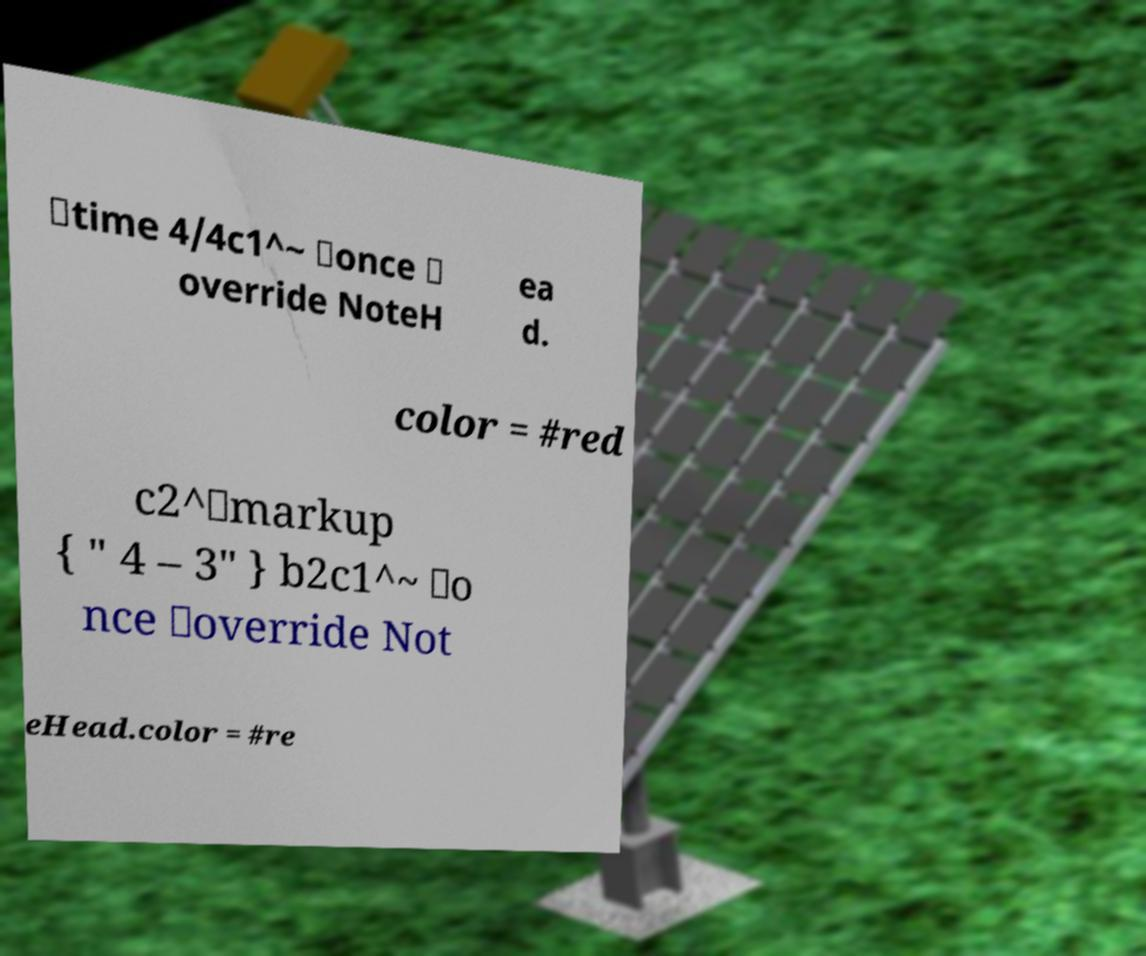Can you read and provide the text displayed in the image?This photo seems to have some interesting text. Can you extract and type it out for me? \time 4/4c1^~ \once \ override NoteH ea d. color = #red c2^\markup { " 4 – 3" } b2c1^~ \o nce \override Not eHead.color = #re 